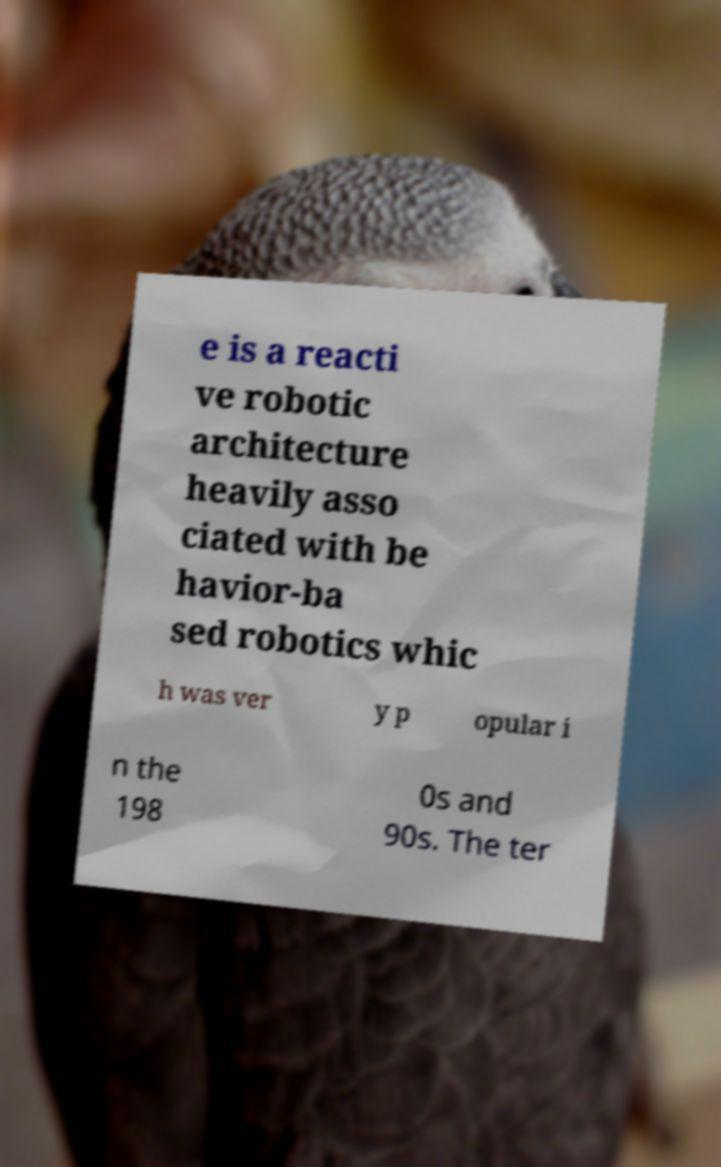I need the written content from this picture converted into text. Can you do that? e is a reacti ve robotic architecture heavily asso ciated with be havior-ba sed robotics whic h was ver y p opular i n the 198 0s and 90s. The ter 